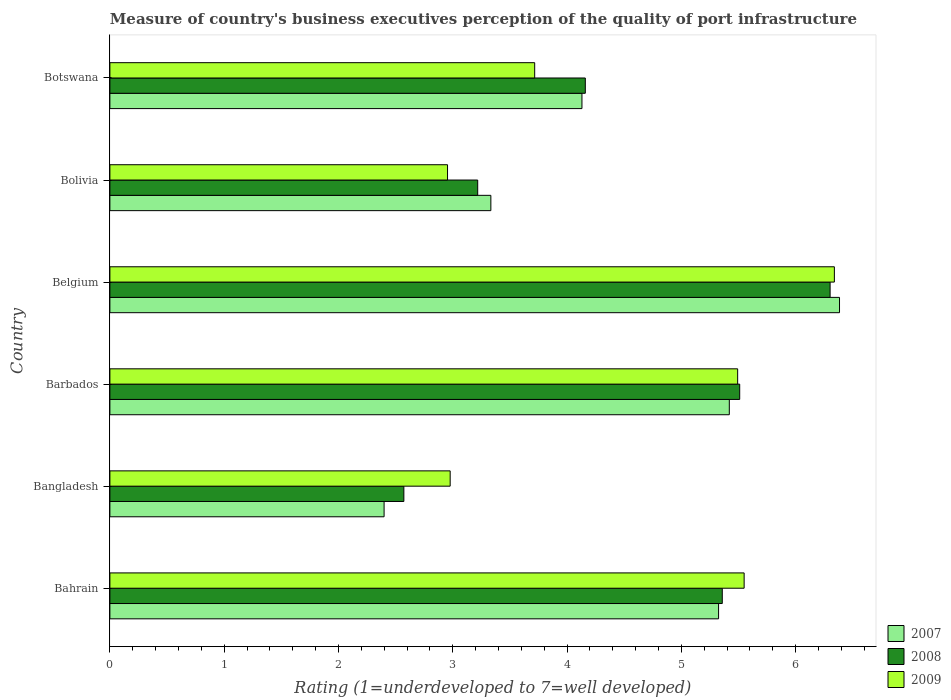How many different coloured bars are there?
Provide a short and direct response. 3. Are the number of bars on each tick of the Y-axis equal?
Provide a succinct answer. Yes. How many bars are there on the 4th tick from the top?
Ensure brevity in your answer.  3. How many bars are there on the 3rd tick from the bottom?
Your response must be concise. 3. What is the label of the 1st group of bars from the top?
Provide a succinct answer. Botswana. In how many cases, is the number of bars for a given country not equal to the number of legend labels?
Provide a succinct answer. 0. What is the ratings of the quality of port infrastructure in 2009 in Botswana?
Give a very brief answer. 3.72. Across all countries, what is the maximum ratings of the quality of port infrastructure in 2008?
Provide a short and direct response. 6.3. Across all countries, what is the minimum ratings of the quality of port infrastructure in 2009?
Provide a succinct answer. 2.95. In which country was the ratings of the quality of port infrastructure in 2007 maximum?
Provide a succinct answer. Belgium. In which country was the ratings of the quality of port infrastructure in 2008 minimum?
Make the answer very short. Bangladesh. What is the total ratings of the quality of port infrastructure in 2008 in the graph?
Offer a terse response. 27.12. What is the difference between the ratings of the quality of port infrastructure in 2008 in Barbados and that in Belgium?
Your response must be concise. -0.79. What is the difference between the ratings of the quality of port infrastructure in 2008 in Barbados and the ratings of the quality of port infrastructure in 2007 in Botswana?
Offer a terse response. 1.38. What is the average ratings of the quality of port infrastructure in 2008 per country?
Your answer should be compact. 4.52. What is the difference between the ratings of the quality of port infrastructure in 2007 and ratings of the quality of port infrastructure in 2009 in Bolivia?
Offer a very short reply. 0.38. In how many countries, is the ratings of the quality of port infrastructure in 2008 greater than 4.4 ?
Ensure brevity in your answer.  3. What is the ratio of the ratings of the quality of port infrastructure in 2008 in Bangladesh to that in Botswana?
Ensure brevity in your answer.  0.62. Is the difference between the ratings of the quality of port infrastructure in 2007 in Barbados and Bolivia greater than the difference between the ratings of the quality of port infrastructure in 2009 in Barbados and Bolivia?
Ensure brevity in your answer.  No. What is the difference between the highest and the second highest ratings of the quality of port infrastructure in 2007?
Give a very brief answer. 0.96. What is the difference between the highest and the lowest ratings of the quality of port infrastructure in 2009?
Give a very brief answer. 3.38. Is the sum of the ratings of the quality of port infrastructure in 2008 in Belgium and Bolivia greater than the maximum ratings of the quality of port infrastructure in 2009 across all countries?
Ensure brevity in your answer.  Yes. What does the 2nd bar from the bottom in Bolivia represents?
Ensure brevity in your answer.  2008. Is it the case that in every country, the sum of the ratings of the quality of port infrastructure in 2009 and ratings of the quality of port infrastructure in 2007 is greater than the ratings of the quality of port infrastructure in 2008?
Your response must be concise. Yes. How many bars are there?
Give a very brief answer. 18. Are all the bars in the graph horizontal?
Make the answer very short. Yes. How many countries are there in the graph?
Provide a succinct answer. 6. Are the values on the major ticks of X-axis written in scientific E-notation?
Offer a very short reply. No. Does the graph contain any zero values?
Your answer should be very brief. No. Does the graph contain grids?
Keep it short and to the point. No. How are the legend labels stacked?
Keep it short and to the point. Vertical. What is the title of the graph?
Ensure brevity in your answer.  Measure of country's business executives perception of the quality of port infrastructure. Does "1996" appear as one of the legend labels in the graph?
Offer a terse response. No. What is the label or title of the X-axis?
Provide a short and direct response. Rating (1=underdeveloped to 7=well developed). What is the Rating (1=underdeveloped to 7=well developed) of 2007 in Bahrain?
Keep it short and to the point. 5.33. What is the Rating (1=underdeveloped to 7=well developed) of 2008 in Bahrain?
Ensure brevity in your answer.  5.36. What is the Rating (1=underdeveloped to 7=well developed) of 2009 in Bahrain?
Your answer should be very brief. 5.55. What is the Rating (1=underdeveloped to 7=well developed) in 2007 in Bangladesh?
Provide a short and direct response. 2.4. What is the Rating (1=underdeveloped to 7=well developed) of 2008 in Bangladesh?
Give a very brief answer. 2.57. What is the Rating (1=underdeveloped to 7=well developed) of 2009 in Bangladesh?
Ensure brevity in your answer.  2.98. What is the Rating (1=underdeveloped to 7=well developed) of 2007 in Barbados?
Provide a succinct answer. 5.42. What is the Rating (1=underdeveloped to 7=well developed) in 2008 in Barbados?
Your answer should be compact. 5.51. What is the Rating (1=underdeveloped to 7=well developed) of 2009 in Barbados?
Make the answer very short. 5.49. What is the Rating (1=underdeveloped to 7=well developed) in 2007 in Belgium?
Your response must be concise. 6.38. What is the Rating (1=underdeveloped to 7=well developed) of 2008 in Belgium?
Provide a short and direct response. 6.3. What is the Rating (1=underdeveloped to 7=well developed) in 2009 in Belgium?
Offer a terse response. 6.34. What is the Rating (1=underdeveloped to 7=well developed) in 2007 in Bolivia?
Provide a short and direct response. 3.33. What is the Rating (1=underdeveloped to 7=well developed) of 2008 in Bolivia?
Your answer should be compact. 3.22. What is the Rating (1=underdeveloped to 7=well developed) of 2009 in Bolivia?
Your answer should be very brief. 2.95. What is the Rating (1=underdeveloped to 7=well developed) in 2007 in Botswana?
Ensure brevity in your answer.  4.13. What is the Rating (1=underdeveloped to 7=well developed) of 2008 in Botswana?
Your answer should be very brief. 4.16. What is the Rating (1=underdeveloped to 7=well developed) of 2009 in Botswana?
Your response must be concise. 3.72. Across all countries, what is the maximum Rating (1=underdeveloped to 7=well developed) in 2007?
Offer a very short reply. 6.38. Across all countries, what is the maximum Rating (1=underdeveloped to 7=well developed) of 2008?
Offer a very short reply. 6.3. Across all countries, what is the maximum Rating (1=underdeveloped to 7=well developed) in 2009?
Provide a short and direct response. 6.34. Across all countries, what is the minimum Rating (1=underdeveloped to 7=well developed) in 2007?
Keep it short and to the point. 2.4. Across all countries, what is the minimum Rating (1=underdeveloped to 7=well developed) in 2008?
Make the answer very short. 2.57. Across all countries, what is the minimum Rating (1=underdeveloped to 7=well developed) in 2009?
Make the answer very short. 2.95. What is the total Rating (1=underdeveloped to 7=well developed) in 2007 in the graph?
Provide a succinct answer. 26.99. What is the total Rating (1=underdeveloped to 7=well developed) of 2008 in the graph?
Make the answer very short. 27.12. What is the total Rating (1=underdeveloped to 7=well developed) of 2009 in the graph?
Keep it short and to the point. 27.03. What is the difference between the Rating (1=underdeveloped to 7=well developed) in 2007 in Bahrain and that in Bangladesh?
Make the answer very short. 2.93. What is the difference between the Rating (1=underdeveloped to 7=well developed) in 2008 in Bahrain and that in Bangladesh?
Make the answer very short. 2.79. What is the difference between the Rating (1=underdeveloped to 7=well developed) in 2009 in Bahrain and that in Bangladesh?
Provide a succinct answer. 2.57. What is the difference between the Rating (1=underdeveloped to 7=well developed) of 2007 in Bahrain and that in Barbados?
Make the answer very short. -0.09. What is the difference between the Rating (1=underdeveloped to 7=well developed) in 2008 in Bahrain and that in Barbados?
Ensure brevity in your answer.  -0.15. What is the difference between the Rating (1=underdeveloped to 7=well developed) of 2009 in Bahrain and that in Barbados?
Give a very brief answer. 0.06. What is the difference between the Rating (1=underdeveloped to 7=well developed) in 2007 in Bahrain and that in Belgium?
Keep it short and to the point. -1.06. What is the difference between the Rating (1=underdeveloped to 7=well developed) in 2008 in Bahrain and that in Belgium?
Your answer should be compact. -0.94. What is the difference between the Rating (1=underdeveloped to 7=well developed) in 2009 in Bahrain and that in Belgium?
Provide a succinct answer. -0.79. What is the difference between the Rating (1=underdeveloped to 7=well developed) in 2007 in Bahrain and that in Bolivia?
Ensure brevity in your answer.  1.99. What is the difference between the Rating (1=underdeveloped to 7=well developed) of 2008 in Bahrain and that in Bolivia?
Offer a very short reply. 2.14. What is the difference between the Rating (1=underdeveloped to 7=well developed) in 2009 in Bahrain and that in Bolivia?
Provide a succinct answer. 2.6. What is the difference between the Rating (1=underdeveloped to 7=well developed) in 2007 in Bahrain and that in Botswana?
Offer a very short reply. 1.2. What is the difference between the Rating (1=underdeveloped to 7=well developed) of 2008 in Bahrain and that in Botswana?
Offer a very short reply. 1.2. What is the difference between the Rating (1=underdeveloped to 7=well developed) in 2009 in Bahrain and that in Botswana?
Your response must be concise. 1.83. What is the difference between the Rating (1=underdeveloped to 7=well developed) in 2007 in Bangladesh and that in Barbados?
Your answer should be very brief. -3.02. What is the difference between the Rating (1=underdeveloped to 7=well developed) of 2008 in Bangladesh and that in Barbados?
Your answer should be compact. -2.94. What is the difference between the Rating (1=underdeveloped to 7=well developed) in 2009 in Bangladesh and that in Barbados?
Offer a very short reply. -2.52. What is the difference between the Rating (1=underdeveloped to 7=well developed) in 2007 in Bangladesh and that in Belgium?
Your answer should be very brief. -3.98. What is the difference between the Rating (1=underdeveloped to 7=well developed) of 2008 in Bangladesh and that in Belgium?
Provide a succinct answer. -3.73. What is the difference between the Rating (1=underdeveloped to 7=well developed) in 2009 in Bangladesh and that in Belgium?
Your answer should be compact. -3.36. What is the difference between the Rating (1=underdeveloped to 7=well developed) of 2007 in Bangladesh and that in Bolivia?
Keep it short and to the point. -0.93. What is the difference between the Rating (1=underdeveloped to 7=well developed) of 2008 in Bangladesh and that in Bolivia?
Keep it short and to the point. -0.65. What is the difference between the Rating (1=underdeveloped to 7=well developed) in 2009 in Bangladesh and that in Bolivia?
Provide a short and direct response. 0.02. What is the difference between the Rating (1=underdeveloped to 7=well developed) in 2007 in Bangladesh and that in Botswana?
Provide a succinct answer. -1.73. What is the difference between the Rating (1=underdeveloped to 7=well developed) of 2008 in Bangladesh and that in Botswana?
Keep it short and to the point. -1.59. What is the difference between the Rating (1=underdeveloped to 7=well developed) in 2009 in Bangladesh and that in Botswana?
Provide a short and direct response. -0.74. What is the difference between the Rating (1=underdeveloped to 7=well developed) in 2007 in Barbados and that in Belgium?
Your answer should be compact. -0.96. What is the difference between the Rating (1=underdeveloped to 7=well developed) of 2008 in Barbados and that in Belgium?
Provide a short and direct response. -0.79. What is the difference between the Rating (1=underdeveloped to 7=well developed) in 2009 in Barbados and that in Belgium?
Offer a very short reply. -0.85. What is the difference between the Rating (1=underdeveloped to 7=well developed) in 2007 in Barbados and that in Bolivia?
Provide a succinct answer. 2.09. What is the difference between the Rating (1=underdeveloped to 7=well developed) in 2008 in Barbados and that in Bolivia?
Provide a short and direct response. 2.29. What is the difference between the Rating (1=underdeveloped to 7=well developed) in 2009 in Barbados and that in Bolivia?
Provide a short and direct response. 2.54. What is the difference between the Rating (1=underdeveloped to 7=well developed) of 2007 in Barbados and that in Botswana?
Offer a terse response. 1.29. What is the difference between the Rating (1=underdeveloped to 7=well developed) in 2008 in Barbados and that in Botswana?
Offer a very short reply. 1.35. What is the difference between the Rating (1=underdeveloped to 7=well developed) in 2009 in Barbados and that in Botswana?
Your response must be concise. 1.78. What is the difference between the Rating (1=underdeveloped to 7=well developed) in 2007 in Belgium and that in Bolivia?
Keep it short and to the point. 3.05. What is the difference between the Rating (1=underdeveloped to 7=well developed) of 2008 in Belgium and that in Bolivia?
Give a very brief answer. 3.08. What is the difference between the Rating (1=underdeveloped to 7=well developed) of 2009 in Belgium and that in Bolivia?
Offer a terse response. 3.38. What is the difference between the Rating (1=underdeveloped to 7=well developed) in 2007 in Belgium and that in Botswana?
Ensure brevity in your answer.  2.25. What is the difference between the Rating (1=underdeveloped to 7=well developed) of 2008 in Belgium and that in Botswana?
Provide a succinct answer. 2.14. What is the difference between the Rating (1=underdeveloped to 7=well developed) of 2009 in Belgium and that in Botswana?
Offer a very short reply. 2.62. What is the difference between the Rating (1=underdeveloped to 7=well developed) in 2007 in Bolivia and that in Botswana?
Make the answer very short. -0.8. What is the difference between the Rating (1=underdeveloped to 7=well developed) in 2008 in Bolivia and that in Botswana?
Your answer should be very brief. -0.94. What is the difference between the Rating (1=underdeveloped to 7=well developed) in 2009 in Bolivia and that in Botswana?
Ensure brevity in your answer.  -0.76. What is the difference between the Rating (1=underdeveloped to 7=well developed) of 2007 in Bahrain and the Rating (1=underdeveloped to 7=well developed) of 2008 in Bangladesh?
Keep it short and to the point. 2.75. What is the difference between the Rating (1=underdeveloped to 7=well developed) in 2007 in Bahrain and the Rating (1=underdeveloped to 7=well developed) in 2009 in Bangladesh?
Your answer should be compact. 2.35. What is the difference between the Rating (1=underdeveloped to 7=well developed) of 2008 in Bahrain and the Rating (1=underdeveloped to 7=well developed) of 2009 in Bangladesh?
Keep it short and to the point. 2.38. What is the difference between the Rating (1=underdeveloped to 7=well developed) of 2007 in Bahrain and the Rating (1=underdeveloped to 7=well developed) of 2008 in Barbados?
Give a very brief answer. -0.18. What is the difference between the Rating (1=underdeveloped to 7=well developed) of 2007 in Bahrain and the Rating (1=underdeveloped to 7=well developed) of 2009 in Barbados?
Your answer should be compact. -0.17. What is the difference between the Rating (1=underdeveloped to 7=well developed) of 2008 in Bahrain and the Rating (1=underdeveloped to 7=well developed) of 2009 in Barbados?
Give a very brief answer. -0.13. What is the difference between the Rating (1=underdeveloped to 7=well developed) in 2007 in Bahrain and the Rating (1=underdeveloped to 7=well developed) in 2008 in Belgium?
Keep it short and to the point. -0.98. What is the difference between the Rating (1=underdeveloped to 7=well developed) of 2007 in Bahrain and the Rating (1=underdeveloped to 7=well developed) of 2009 in Belgium?
Provide a short and direct response. -1.01. What is the difference between the Rating (1=underdeveloped to 7=well developed) in 2008 in Bahrain and the Rating (1=underdeveloped to 7=well developed) in 2009 in Belgium?
Offer a terse response. -0.98. What is the difference between the Rating (1=underdeveloped to 7=well developed) in 2007 in Bahrain and the Rating (1=underdeveloped to 7=well developed) in 2008 in Bolivia?
Offer a very short reply. 2.11. What is the difference between the Rating (1=underdeveloped to 7=well developed) in 2007 in Bahrain and the Rating (1=underdeveloped to 7=well developed) in 2009 in Bolivia?
Ensure brevity in your answer.  2.37. What is the difference between the Rating (1=underdeveloped to 7=well developed) in 2008 in Bahrain and the Rating (1=underdeveloped to 7=well developed) in 2009 in Bolivia?
Keep it short and to the point. 2.4. What is the difference between the Rating (1=underdeveloped to 7=well developed) of 2007 in Bahrain and the Rating (1=underdeveloped to 7=well developed) of 2008 in Botswana?
Your answer should be very brief. 1.17. What is the difference between the Rating (1=underdeveloped to 7=well developed) of 2007 in Bahrain and the Rating (1=underdeveloped to 7=well developed) of 2009 in Botswana?
Offer a very short reply. 1.61. What is the difference between the Rating (1=underdeveloped to 7=well developed) of 2008 in Bahrain and the Rating (1=underdeveloped to 7=well developed) of 2009 in Botswana?
Offer a terse response. 1.64. What is the difference between the Rating (1=underdeveloped to 7=well developed) in 2007 in Bangladesh and the Rating (1=underdeveloped to 7=well developed) in 2008 in Barbados?
Give a very brief answer. -3.11. What is the difference between the Rating (1=underdeveloped to 7=well developed) in 2007 in Bangladesh and the Rating (1=underdeveloped to 7=well developed) in 2009 in Barbados?
Provide a succinct answer. -3.09. What is the difference between the Rating (1=underdeveloped to 7=well developed) in 2008 in Bangladesh and the Rating (1=underdeveloped to 7=well developed) in 2009 in Barbados?
Your answer should be compact. -2.92. What is the difference between the Rating (1=underdeveloped to 7=well developed) in 2007 in Bangladesh and the Rating (1=underdeveloped to 7=well developed) in 2008 in Belgium?
Your answer should be compact. -3.9. What is the difference between the Rating (1=underdeveloped to 7=well developed) in 2007 in Bangladesh and the Rating (1=underdeveloped to 7=well developed) in 2009 in Belgium?
Give a very brief answer. -3.94. What is the difference between the Rating (1=underdeveloped to 7=well developed) in 2008 in Bangladesh and the Rating (1=underdeveloped to 7=well developed) in 2009 in Belgium?
Provide a succinct answer. -3.77. What is the difference between the Rating (1=underdeveloped to 7=well developed) in 2007 in Bangladesh and the Rating (1=underdeveloped to 7=well developed) in 2008 in Bolivia?
Offer a very short reply. -0.82. What is the difference between the Rating (1=underdeveloped to 7=well developed) of 2007 in Bangladesh and the Rating (1=underdeveloped to 7=well developed) of 2009 in Bolivia?
Keep it short and to the point. -0.56. What is the difference between the Rating (1=underdeveloped to 7=well developed) in 2008 in Bangladesh and the Rating (1=underdeveloped to 7=well developed) in 2009 in Bolivia?
Offer a terse response. -0.38. What is the difference between the Rating (1=underdeveloped to 7=well developed) in 2007 in Bangladesh and the Rating (1=underdeveloped to 7=well developed) in 2008 in Botswana?
Your answer should be compact. -1.76. What is the difference between the Rating (1=underdeveloped to 7=well developed) of 2007 in Bangladesh and the Rating (1=underdeveloped to 7=well developed) of 2009 in Botswana?
Provide a succinct answer. -1.32. What is the difference between the Rating (1=underdeveloped to 7=well developed) in 2008 in Bangladesh and the Rating (1=underdeveloped to 7=well developed) in 2009 in Botswana?
Ensure brevity in your answer.  -1.14. What is the difference between the Rating (1=underdeveloped to 7=well developed) in 2007 in Barbados and the Rating (1=underdeveloped to 7=well developed) in 2008 in Belgium?
Make the answer very short. -0.88. What is the difference between the Rating (1=underdeveloped to 7=well developed) in 2007 in Barbados and the Rating (1=underdeveloped to 7=well developed) in 2009 in Belgium?
Keep it short and to the point. -0.92. What is the difference between the Rating (1=underdeveloped to 7=well developed) of 2008 in Barbados and the Rating (1=underdeveloped to 7=well developed) of 2009 in Belgium?
Offer a terse response. -0.83. What is the difference between the Rating (1=underdeveloped to 7=well developed) in 2007 in Barbados and the Rating (1=underdeveloped to 7=well developed) in 2008 in Bolivia?
Give a very brief answer. 2.2. What is the difference between the Rating (1=underdeveloped to 7=well developed) in 2007 in Barbados and the Rating (1=underdeveloped to 7=well developed) in 2009 in Bolivia?
Give a very brief answer. 2.47. What is the difference between the Rating (1=underdeveloped to 7=well developed) in 2008 in Barbados and the Rating (1=underdeveloped to 7=well developed) in 2009 in Bolivia?
Give a very brief answer. 2.56. What is the difference between the Rating (1=underdeveloped to 7=well developed) in 2007 in Barbados and the Rating (1=underdeveloped to 7=well developed) in 2008 in Botswana?
Your answer should be very brief. 1.26. What is the difference between the Rating (1=underdeveloped to 7=well developed) in 2007 in Barbados and the Rating (1=underdeveloped to 7=well developed) in 2009 in Botswana?
Provide a succinct answer. 1.7. What is the difference between the Rating (1=underdeveloped to 7=well developed) of 2008 in Barbados and the Rating (1=underdeveloped to 7=well developed) of 2009 in Botswana?
Make the answer very short. 1.79. What is the difference between the Rating (1=underdeveloped to 7=well developed) in 2007 in Belgium and the Rating (1=underdeveloped to 7=well developed) in 2008 in Bolivia?
Provide a short and direct response. 3.17. What is the difference between the Rating (1=underdeveloped to 7=well developed) in 2007 in Belgium and the Rating (1=underdeveloped to 7=well developed) in 2009 in Bolivia?
Your answer should be compact. 3.43. What is the difference between the Rating (1=underdeveloped to 7=well developed) of 2008 in Belgium and the Rating (1=underdeveloped to 7=well developed) of 2009 in Bolivia?
Offer a very short reply. 3.35. What is the difference between the Rating (1=underdeveloped to 7=well developed) of 2007 in Belgium and the Rating (1=underdeveloped to 7=well developed) of 2008 in Botswana?
Ensure brevity in your answer.  2.22. What is the difference between the Rating (1=underdeveloped to 7=well developed) of 2007 in Belgium and the Rating (1=underdeveloped to 7=well developed) of 2009 in Botswana?
Provide a succinct answer. 2.67. What is the difference between the Rating (1=underdeveloped to 7=well developed) in 2008 in Belgium and the Rating (1=underdeveloped to 7=well developed) in 2009 in Botswana?
Ensure brevity in your answer.  2.58. What is the difference between the Rating (1=underdeveloped to 7=well developed) in 2007 in Bolivia and the Rating (1=underdeveloped to 7=well developed) in 2008 in Botswana?
Keep it short and to the point. -0.83. What is the difference between the Rating (1=underdeveloped to 7=well developed) of 2007 in Bolivia and the Rating (1=underdeveloped to 7=well developed) of 2009 in Botswana?
Provide a succinct answer. -0.38. What is the difference between the Rating (1=underdeveloped to 7=well developed) in 2008 in Bolivia and the Rating (1=underdeveloped to 7=well developed) in 2009 in Botswana?
Provide a succinct answer. -0.5. What is the average Rating (1=underdeveloped to 7=well developed) in 2007 per country?
Give a very brief answer. 4.5. What is the average Rating (1=underdeveloped to 7=well developed) of 2008 per country?
Your answer should be compact. 4.52. What is the average Rating (1=underdeveloped to 7=well developed) of 2009 per country?
Your answer should be very brief. 4.5. What is the difference between the Rating (1=underdeveloped to 7=well developed) of 2007 and Rating (1=underdeveloped to 7=well developed) of 2008 in Bahrain?
Your answer should be very brief. -0.03. What is the difference between the Rating (1=underdeveloped to 7=well developed) in 2007 and Rating (1=underdeveloped to 7=well developed) in 2009 in Bahrain?
Make the answer very short. -0.22. What is the difference between the Rating (1=underdeveloped to 7=well developed) of 2008 and Rating (1=underdeveloped to 7=well developed) of 2009 in Bahrain?
Offer a very short reply. -0.19. What is the difference between the Rating (1=underdeveloped to 7=well developed) of 2007 and Rating (1=underdeveloped to 7=well developed) of 2008 in Bangladesh?
Make the answer very short. -0.17. What is the difference between the Rating (1=underdeveloped to 7=well developed) of 2007 and Rating (1=underdeveloped to 7=well developed) of 2009 in Bangladesh?
Your answer should be compact. -0.58. What is the difference between the Rating (1=underdeveloped to 7=well developed) in 2008 and Rating (1=underdeveloped to 7=well developed) in 2009 in Bangladesh?
Offer a very short reply. -0.41. What is the difference between the Rating (1=underdeveloped to 7=well developed) in 2007 and Rating (1=underdeveloped to 7=well developed) in 2008 in Barbados?
Your answer should be very brief. -0.09. What is the difference between the Rating (1=underdeveloped to 7=well developed) in 2007 and Rating (1=underdeveloped to 7=well developed) in 2009 in Barbados?
Ensure brevity in your answer.  -0.07. What is the difference between the Rating (1=underdeveloped to 7=well developed) of 2008 and Rating (1=underdeveloped to 7=well developed) of 2009 in Barbados?
Make the answer very short. 0.02. What is the difference between the Rating (1=underdeveloped to 7=well developed) in 2007 and Rating (1=underdeveloped to 7=well developed) in 2008 in Belgium?
Provide a succinct answer. 0.08. What is the difference between the Rating (1=underdeveloped to 7=well developed) in 2007 and Rating (1=underdeveloped to 7=well developed) in 2009 in Belgium?
Ensure brevity in your answer.  0.04. What is the difference between the Rating (1=underdeveloped to 7=well developed) of 2008 and Rating (1=underdeveloped to 7=well developed) of 2009 in Belgium?
Offer a very short reply. -0.04. What is the difference between the Rating (1=underdeveloped to 7=well developed) of 2007 and Rating (1=underdeveloped to 7=well developed) of 2008 in Bolivia?
Your answer should be very brief. 0.12. What is the difference between the Rating (1=underdeveloped to 7=well developed) in 2007 and Rating (1=underdeveloped to 7=well developed) in 2009 in Bolivia?
Your response must be concise. 0.38. What is the difference between the Rating (1=underdeveloped to 7=well developed) of 2008 and Rating (1=underdeveloped to 7=well developed) of 2009 in Bolivia?
Keep it short and to the point. 0.26. What is the difference between the Rating (1=underdeveloped to 7=well developed) in 2007 and Rating (1=underdeveloped to 7=well developed) in 2008 in Botswana?
Make the answer very short. -0.03. What is the difference between the Rating (1=underdeveloped to 7=well developed) in 2007 and Rating (1=underdeveloped to 7=well developed) in 2009 in Botswana?
Your response must be concise. 0.41. What is the difference between the Rating (1=underdeveloped to 7=well developed) in 2008 and Rating (1=underdeveloped to 7=well developed) in 2009 in Botswana?
Offer a very short reply. 0.44. What is the ratio of the Rating (1=underdeveloped to 7=well developed) in 2007 in Bahrain to that in Bangladesh?
Keep it short and to the point. 2.22. What is the ratio of the Rating (1=underdeveloped to 7=well developed) in 2008 in Bahrain to that in Bangladesh?
Provide a succinct answer. 2.08. What is the ratio of the Rating (1=underdeveloped to 7=well developed) of 2009 in Bahrain to that in Bangladesh?
Ensure brevity in your answer.  1.86. What is the ratio of the Rating (1=underdeveloped to 7=well developed) of 2007 in Bahrain to that in Barbados?
Offer a very short reply. 0.98. What is the ratio of the Rating (1=underdeveloped to 7=well developed) of 2008 in Bahrain to that in Barbados?
Keep it short and to the point. 0.97. What is the ratio of the Rating (1=underdeveloped to 7=well developed) in 2009 in Bahrain to that in Barbados?
Give a very brief answer. 1.01. What is the ratio of the Rating (1=underdeveloped to 7=well developed) in 2007 in Bahrain to that in Belgium?
Keep it short and to the point. 0.83. What is the ratio of the Rating (1=underdeveloped to 7=well developed) of 2008 in Bahrain to that in Belgium?
Ensure brevity in your answer.  0.85. What is the ratio of the Rating (1=underdeveloped to 7=well developed) in 2009 in Bahrain to that in Belgium?
Make the answer very short. 0.88. What is the ratio of the Rating (1=underdeveloped to 7=well developed) of 2007 in Bahrain to that in Bolivia?
Provide a succinct answer. 1.6. What is the ratio of the Rating (1=underdeveloped to 7=well developed) in 2008 in Bahrain to that in Bolivia?
Offer a terse response. 1.66. What is the ratio of the Rating (1=underdeveloped to 7=well developed) in 2009 in Bahrain to that in Bolivia?
Provide a short and direct response. 1.88. What is the ratio of the Rating (1=underdeveloped to 7=well developed) in 2007 in Bahrain to that in Botswana?
Your response must be concise. 1.29. What is the ratio of the Rating (1=underdeveloped to 7=well developed) of 2008 in Bahrain to that in Botswana?
Provide a succinct answer. 1.29. What is the ratio of the Rating (1=underdeveloped to 7=well developed) in 2009 in Bahrain to that in Botswana?
Your answer should be very brief. 1.49. What is the ratio of the Rating (1=underdeveloped to 7=well developed) of 2007 in Bangladesh to that in Barbados?
Offer a very short reply. 0.44. What is the ratio of the Rating (1=underdeveloped to 7=well developed) of 2008 in Bangladesh to that in Barbados?
Your answer should be compact. 0.47. What is the ratio of the Rating (1=underdeveloped to 7=well developed) of 2009 in Bangladesh to that in Barbados?
Your answer should be very brief. 0.54. What is the ratio of the Rating (1=underdeveloped to 7=well developed) of 2007 in Bangladesh to that in Belgium?
Keep it short and to the point. 0.38. What is the ratio of the Rating (1=underdeveloped to 7=well developed) in 2008 in Bangladesh to that in Belgium?
Provide a succinct answer. 0.41. What is the ratio of the Rating (1=underdeveloped to 7=well developed) in 2009 in Bangladesh to that in Belgium?
Your response must be concise. 0.47. What is the ratio of the Rating (1=underdeveloped to 7=well developed) of 2007 in Bangladesh to that in Bolivia?
Ensure brevity in your answer.  0.72. What is the ratio of the Rating (1=underdeveloped to 7=well developed) in 2008 in Bangladesh to that in Bolivia?
Keep it short and to the point. 0.8. What is the ratio of the Rating (1=underdeveloped to 7=well developed) in 2009 in Bangladesh to that in Bolivia?
Ensure brevity in your answer.  1.01. What is the ratio of the Rating (1=underdeveloped to 7=well developed) in 2007 in Bangladesh to that in Botswana?
Provide a succinct answer. 0.58. What is the ratio of the Rating (1=underdeveloped to 7=well developed) in 2008 in Bangladesh to that in Botswana?
Your answer should be very brief. 0.62. What is the ratio of the Rating (1=underdeveloped to 7=well developed) in 2009 in Bangladesh to that in Botswana?
Make the answer very short. 0.8. What is the ratio of the Rating (1=underdeveloped to 7=well developed) in 2007 in Barbados to that in Belgium?
Your response must be concise. 0.85. What is the ratio of the Rating (1=underdeveloped to 7=well developed) of 2008 in Barbados to that in Belgium?
Ensure brevity in your answer.  0.87. What is the ratio of the Rating (1=underdeveloped to 7=well developed) in 2009 in Barbados to that in Belgium?
Your answer should be very brief. 0.87. What is the ratio of the Rating (1=underdeveloped to 7=well developed) of 2007 in Barbados to that in Bolivia?
Offer a terse response. 1.63. What is the ratio of the Rating (1=underdeveloped to 7=well developed) in 2008 in Barbados to that in Bolivia?
Keep it short and to the point. 1.71. What is the ratio of the Rating (1=underdeveloped to 7=well developed) in 2009 in Barbados to that in Bolivia?
Your response must be concise. 1.86. What is the ratio of the Rating (1=underdeveloped to 7=well developed) of 2007 in Barbados to that in Botswana?
Provide a short and direct response. 1.31. What is the ratio of the Rating (1=underdeveloped to 7=well developed) in 2008 in Barbados to that in Botswana?
Provide a short and direct response. 1.32. What is the ratio of the Rating (1=underdeveloped to 7=well developed) of 2009 in Barbados to that in Botswana?
Offer a terse response. 1.48. What is the ratio of the Rating (1=underdeveloped to 7=well developed) of 2007 in Belgium to that in Bolivia?
Offer a terse response. 1.92. What is the ratio of the Rating (1=underdeveloped to 7=well developed) in 2008 in Belgium to that in Bolivia?
Ensure brevity in your answer.  1.96. What is the ratio of the Rating (1=underdeveloped to 7=well developed) in 2009 in Belgium to that in Bolivia?
Offer a terse response. 2.15. What is the ratio of the Rating (1=underdeveloped to 7=well developed) in 2007 in Belgium to that in Botswana?
Ensure brevity in your answer.  1.55. What is the ratio of the Rating (1=underdeveloped to 7=well developed) in 2008 in Belgium to that in Botswana?
Your answer should be very brief. 1.51. What is the ratio of the Rating (1=underdeveloped to 7=well developed) in 2009 in Belgium to that in Botswana?
Provide a succinct answer. 1.71. What is the ratio of the Rating (1=underdeveloped to 7=well developed) in 2007 in Bolivia to that in Botswana?
Your response must be concise. 0.81. What is the ratio of the Rating (1=underdeveloped to 7=well developed) in 2008 in Bolivia to that in Botswana?
Ensure brevity in your answer.  0.77. What is the ratio of the Rating (1=underdeveloped to 7=well developed) of 2009 in Bolivia to that in Botswana?
Give a very brief answer. 0.79. What is the difference between the highest and the second highest Rating (1=underdeveloped to 7=well developed) in 2007?
Ensure brevity in your answer.  0.96. What is the difference between the highest and the second highest Rating (1=underdeveloped to 7=well developed) in 2008?
Offer a terse response. 0.79. What is the difference between the highest and the second highest Rating (1=underdeveloped to 7=well developed) in 2009?
Make the answer very short. 0.79. What is the difference between the highest and the lowest Rating (1=underdeveloped to 7=well developed) of 2007?
Give a very brief answer. 3.98. What is the difference between the highest and the lowest Rating (1=underdeveloped to 7=well developed) in 2008?
Your answer should be very brief. 3.73. What is the difference between the highest and the lowest Rating (1=underdeveloped to 7=well developed) of 2009?
Provide a succinct answer. 3.38. 